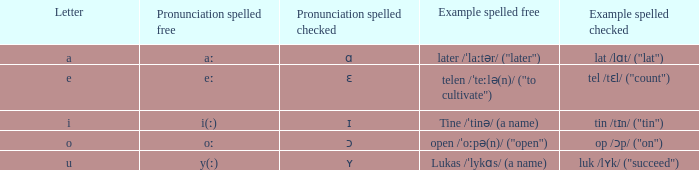What is Letter, when Example Spelled Checked is "tin /tɪn/ ("tin")"? I. 